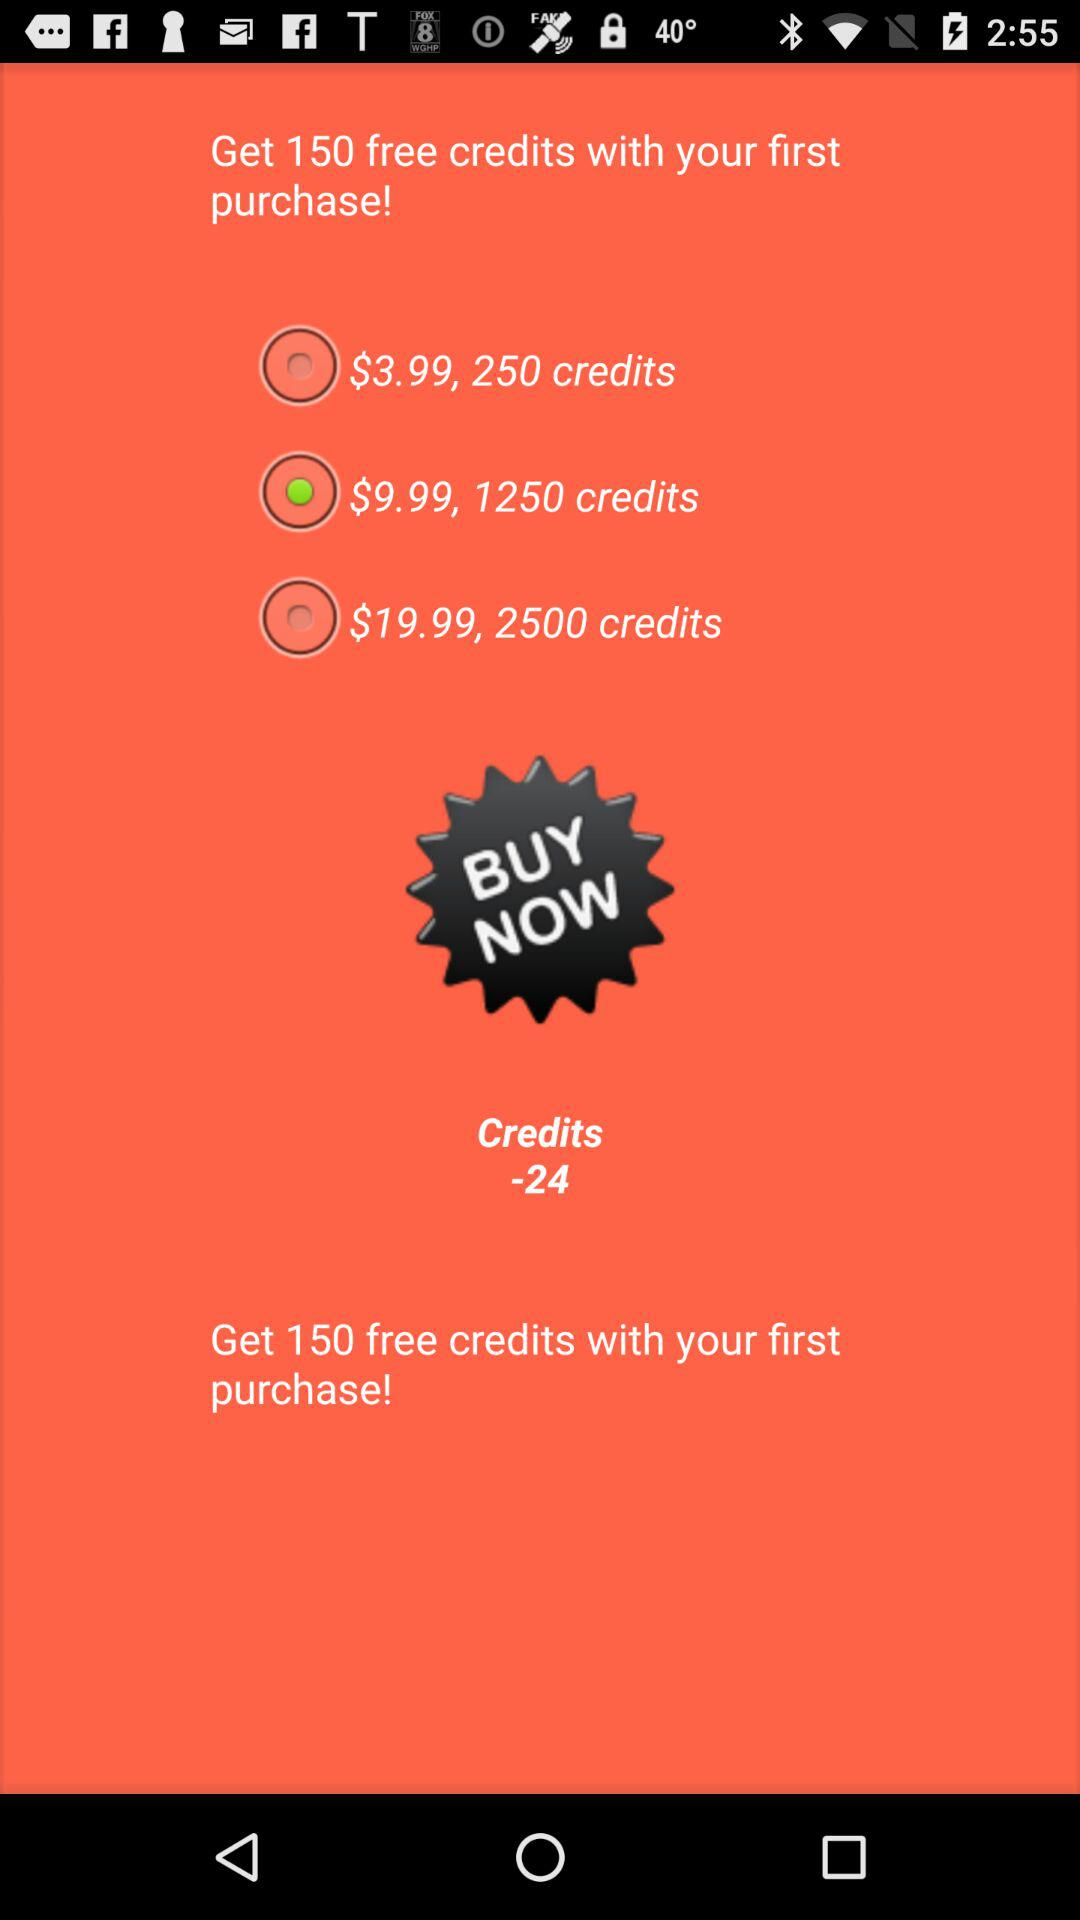How many credits do you get for the most expensive option?
Answer the question using a single word or phrase. 2500 